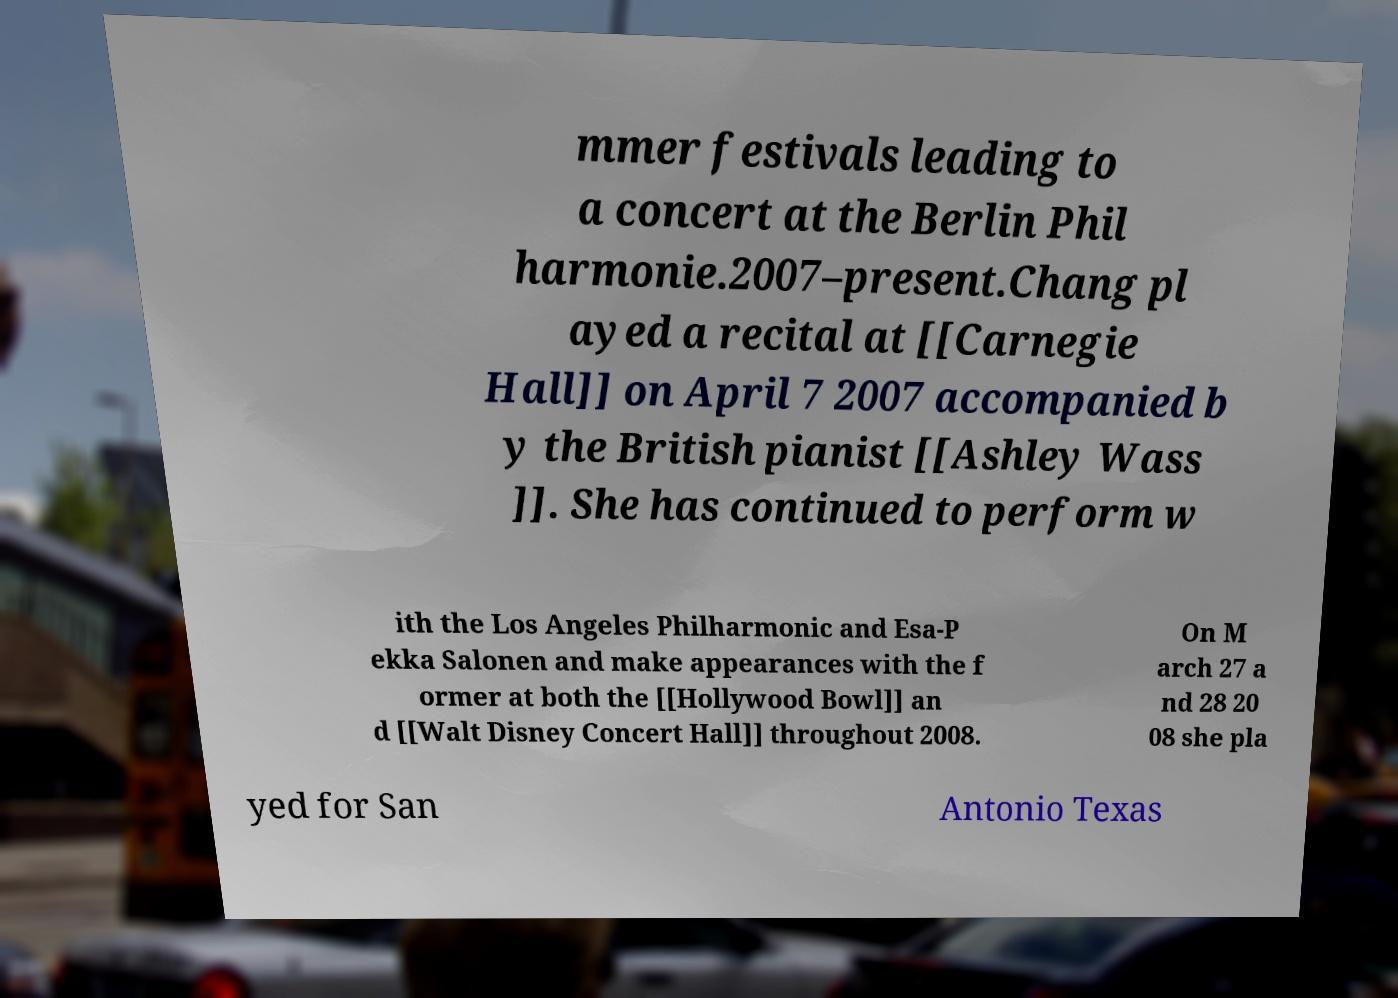Please read and relay the text visible in this image. What does it say? mmer festivals leading to a concert at the Berlin Phil harmonie.2007–present.Chang pl ayed a recital at [[Carnegie Hall]] on April 7 2007 accompanied b y the British pianist [[Ashley Wass ]]. She has continued to perform w ith the Los Angeles Philharmonic and Esa-P ekka Salonen and make appearances with the f ormer at both the [[Hollywood Bowl]] an d [[Walt Disney Concert Hall]] throughout 2008. On M arch 27 a nd 28 20 08 she pla yed for San Antonio Texas 